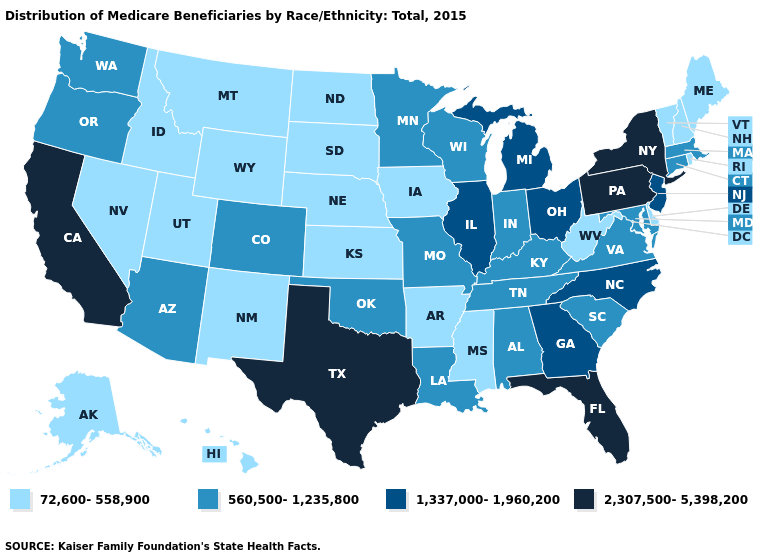What is the value of Kansas?
Answer briefly. 72,600-558,900. Which states hav the highest value in the South?
Be succinct. Florida, Texas. Does the first symbol in the legend represent the smallest category?
Be succinct. Yes. What is the value of Florida?
Short answer required. 2,307,500-5,398,200. Name the states that have a value in the range 1,337,000-1,960,200?
Quick response, please. Georgia, Illinois, Michigan, New Jersey, North Carolina, Ohio. What is the lowest value in the USA?
Answer briefly. 72,600-558,900. Does Vermont have the lowest value in the Northeast?
Concise answer only. Yes. What is the highest value in the MidWest ?
Concise answer only. 1,337,000-1,960,200. Is the legend a continuous bar?
Short answer required. No. What is the value of Utah?
Keep it brief. 72,600-558,900. What is the value of Mississippi?
Be succinct. 72,600-558,900. How many symbols are there in the legend?
Concise answer only. 4. What is the lowest value in states that border Louisiana?
Keep it brief. 72,600-558,900. Among the states that border Indiana , does Ohio have the lowest value?
Write a very short answer. No. Does South Dakota have the lowest value in the MidWest?
Short answer required. Yes. 